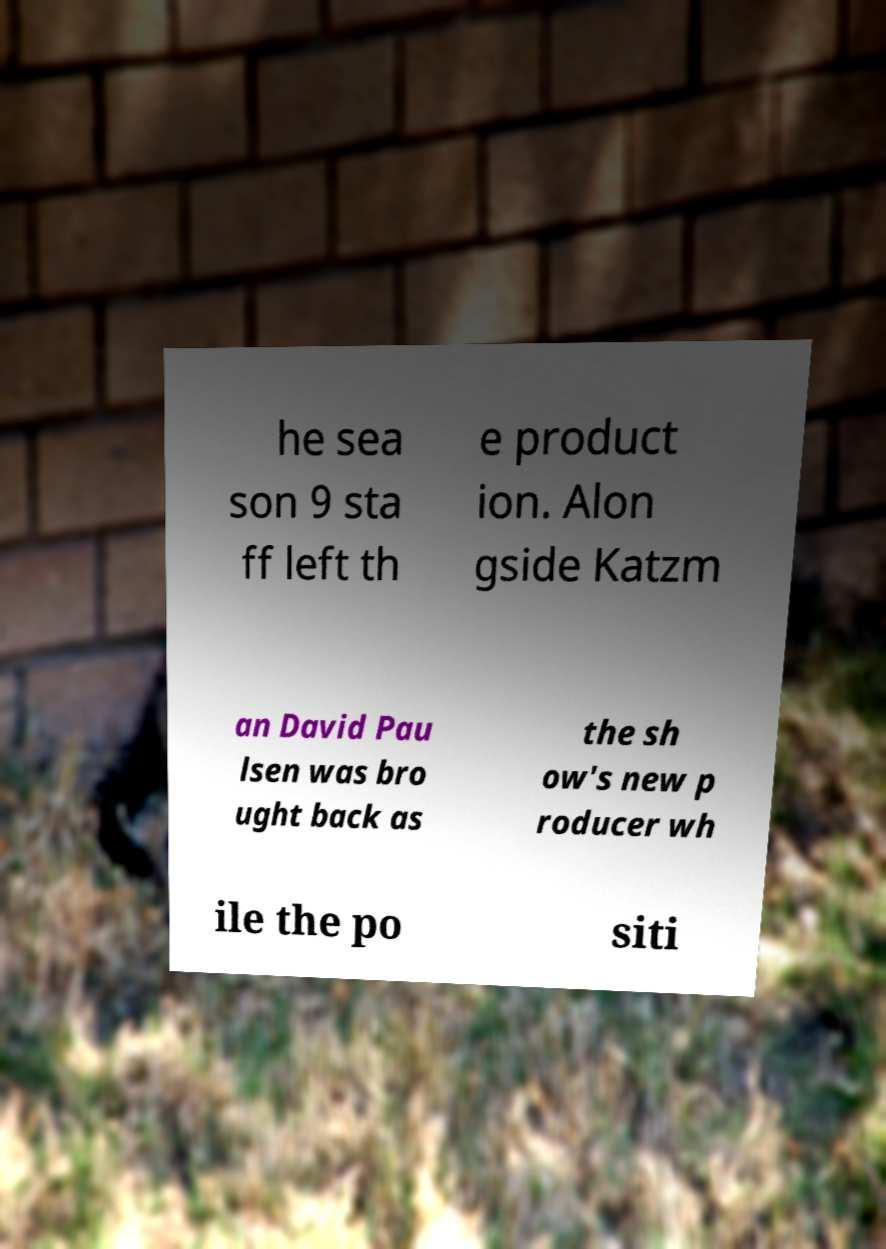There's text embedded in this image that I need extracted. Can you transcribe it verbatim? he sea son 9 sta ff left th e product ion. Alon gside Katzm an David Pau lsen was bro ught back as the sh ow's new p roducer wh ile the po siti 